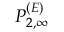<formula> <loc_0><loc_0><loc_500><loc_500>P _ { 2 , \infty } ^ { ( E ) }</formula> 